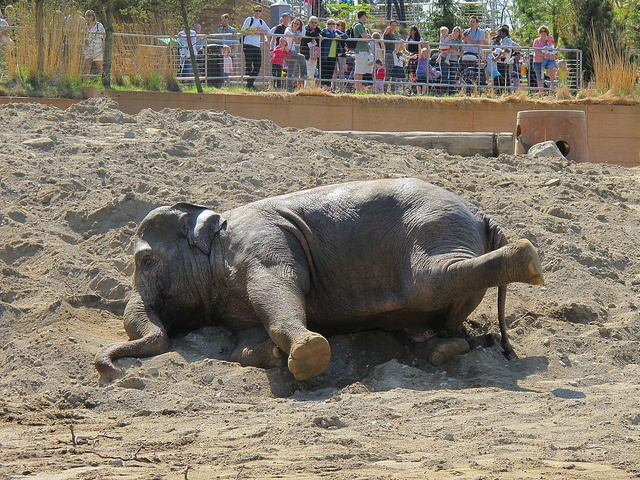Describe the objects in this image and their specific colors. I can see elephant in black, gray, and darkgray tones, people in black, gray, olive, and darkgray tones, people in black, gray, darkgray, and brown tones, people in black, darkgray, and gray tones, and people in black, darkgray, and gray tones in this image. 